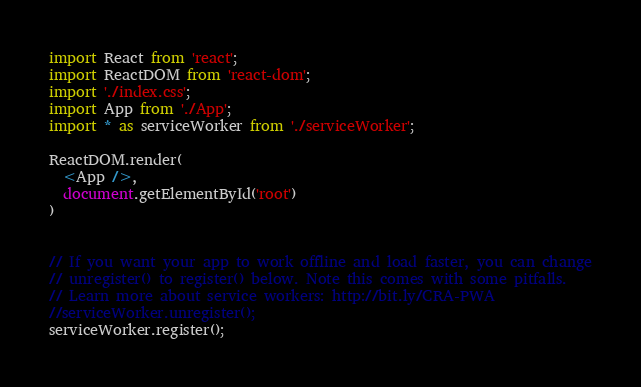Convert code to text. <code><loc_0><loc_0><loc_500><loc_500><_JavaScript_>import React from 'react';
import ReactDOM from 'react-dom';
import './index.css';
import App from './App';
import * as serviceWorker from './serviceWorker';

ReactDOM.render(
  <App />,
  document.getElementById('root')
)


// If you want your app to work offline and load faster, you can change
// unregister() to register() below. Note this comes with some pitfalls.
// Learn more about service workers: http://bit.ly/CRA-PWA
//serviceWorker.unregister();
serviceWorker.register();
</code> 